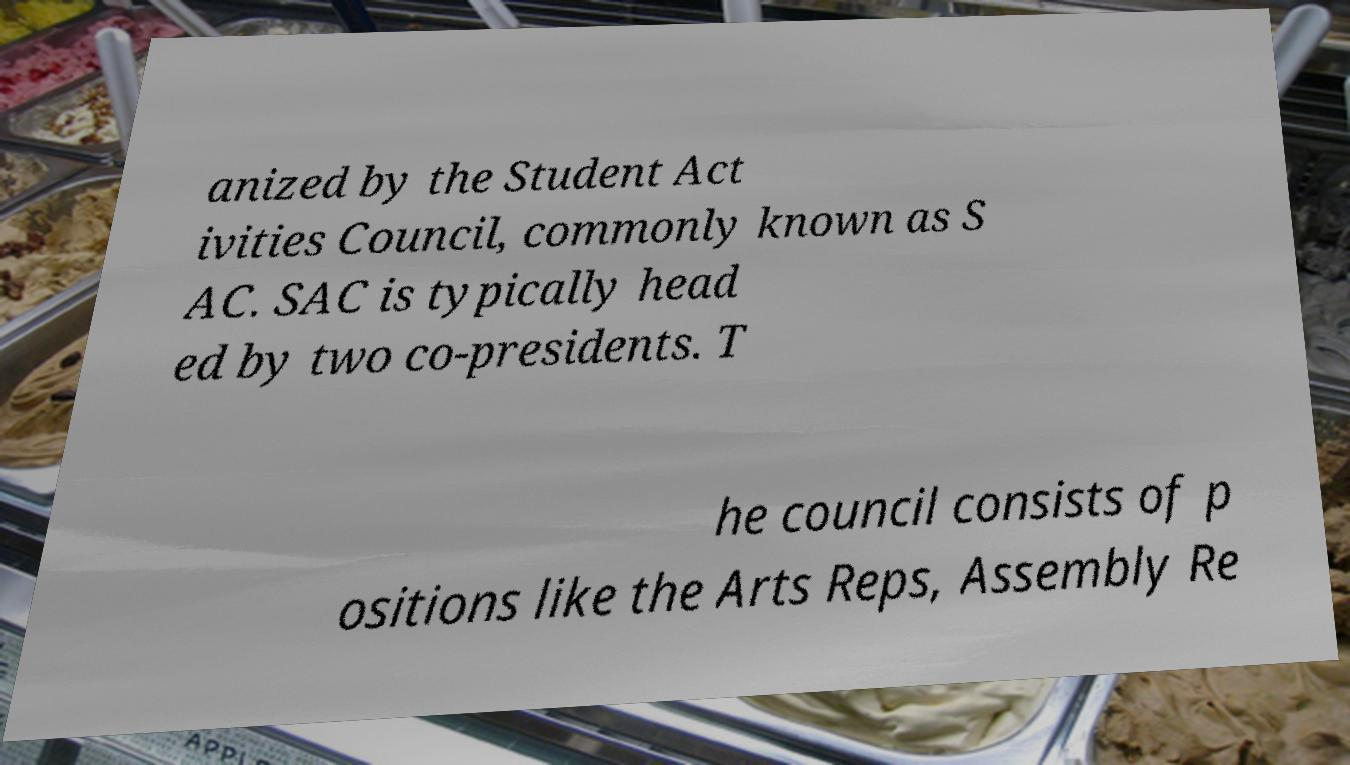Please read and relay the text visible in this image. What does it say? anized by the Student Act ivities Council, commonly known as S AC. SAC is typically head ed by two co-presidents. T he council consists of p ositions like the Arts Reps, Assembly Re 